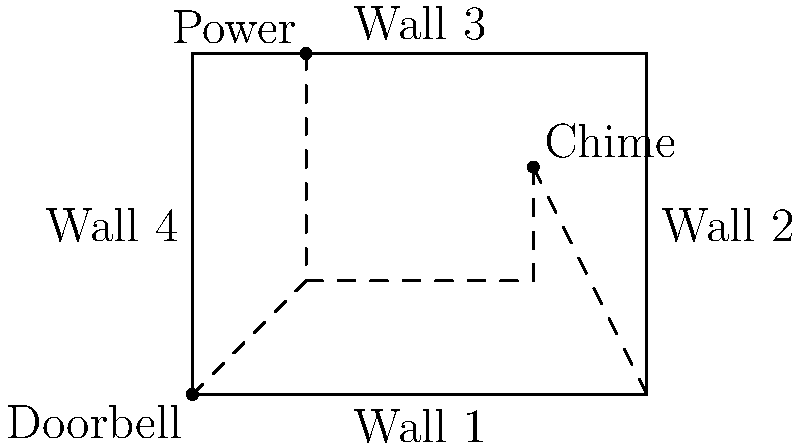In the diagram above, a doorbell system needs to be installed in a rectangular room. The power source is located on Wall 3, the chime is on Wall 2, and the doorbell is at the bottom-left corner. What is the minimum total length of wiring required to connect all three components if the wiring must run along the walls? Given that the room dimensions are 8 feet by 6 feet, express your answer in feet. To find the minimum total length of wiring, we need to determine the shortest path that connects all three components while running along the walls. Let's break this down step-by-step:

1) First, we need to identify the positions of each component:
   - Power source: 2 feet from the left on Wall 3
   - Chime: 6 feet from the left and 4 feet from the bottom on Wall 2
   - Doorbell: At the bottom-left corner (0,0)

2) Now, let's consider the most efficient path:
   a) From the power source to the chime:
      - 4 feet down Wall 4
      - 6 feet along the bottom (Wall 1)
      - 4 feet up Wall 2
   Total for this segment: $4 + 6 + 4 = 14$ feet

   b) From the chime to the doorbell:
      - 4 feet down Wall 2
      - 6 feet along the bottom (Wall 1) to the doorbell
   Total for this segment: $4 + 6 = 10$ feet

3) The total wiring length is the sum of these two segments:
   $14 + 10 = 24$ feet

This path ensures that all components are connected using the minimum amount of wiring while adhering to the requirement of running along the walls.
Answer: 24 feet 